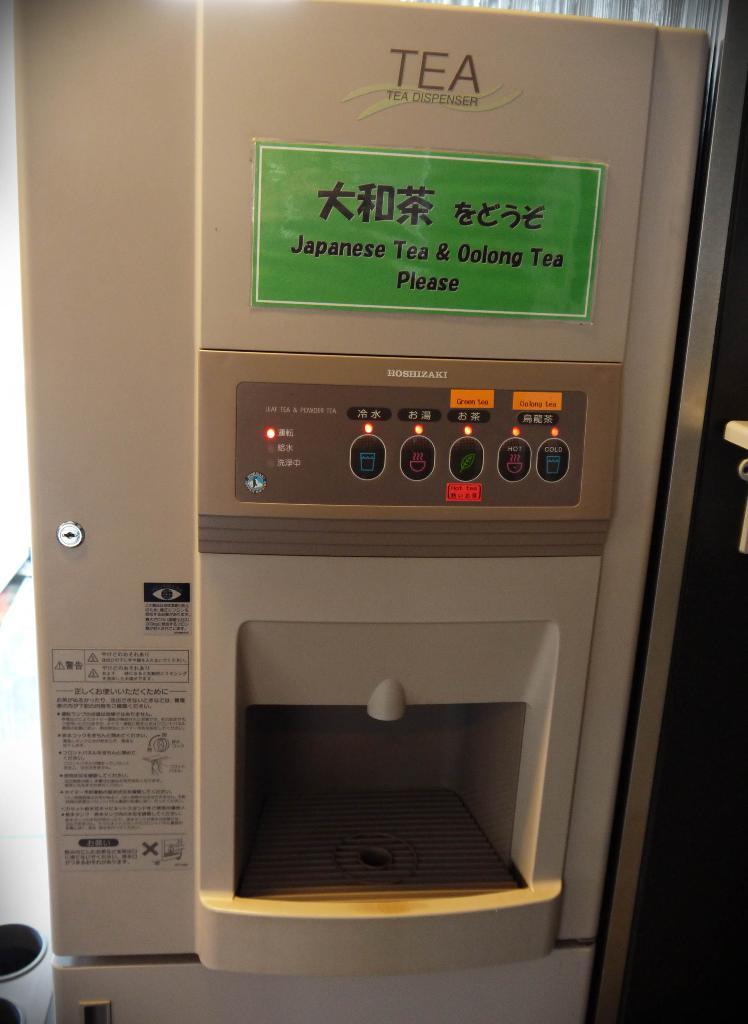Provide a one-sentence caption for the provided image. a vending machine selling Japanese tea and both Japanese and English words. 